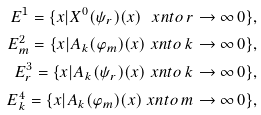Convert formula to latex. <formula><loc_0><loc_0><loc_500><loc_500>E ^ { 1 } = \{ x | X ^ { 0 } ( \psi _ { r } ) ( x ) \ x n t o { \, r \to \infty \, } 0 \} , \\ E ^ { 2 } _ { m } = \{ x | A _ { k } ( \varphi _ { m } ) ( x ) \ x n t o { \, k \to \infty \, } 0 \} , \\ E ^ { 3 } _ { r } = \{ x | A _ { k } ( \psi _ { r } ) ( x ) \ x n t o { \, k \to \infty \, } 0 \} , \\ E ^ { 4 } _ { k } = \{ x | A _ { k } ( \varphi _ { m } ) ( x ) \ x n t o { \, m \to \infty \, } 0 \} ,</formula> 